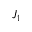<formula> <loc_0><loc_0><loc_500><loc_500>J _ { 1 }</formula> 